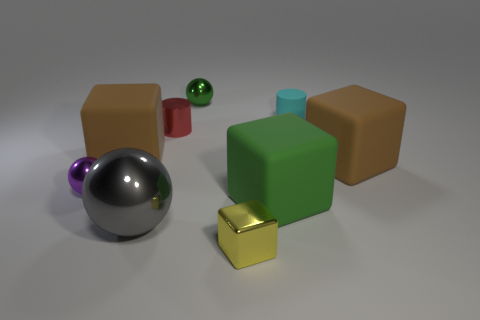What textures can be observed on the surfaces of the objects? The objects exhibit a variety of textures. The spheres have a smooth and shiny finish, reflecting light and their surroundings, whereas the cubes seem to have a matte, slightly rough texture with a subtle sheen, indicating a less reflective material. Do the reflections on the spheres reveal anything about the environment they're in? While the reflections on the spheres are somewhat diffuse, they suggest a lightly textured ceiling or sky and some indication of a wider space around the spheres. The nondescript gray background does not provide much specific detail about the environment. 